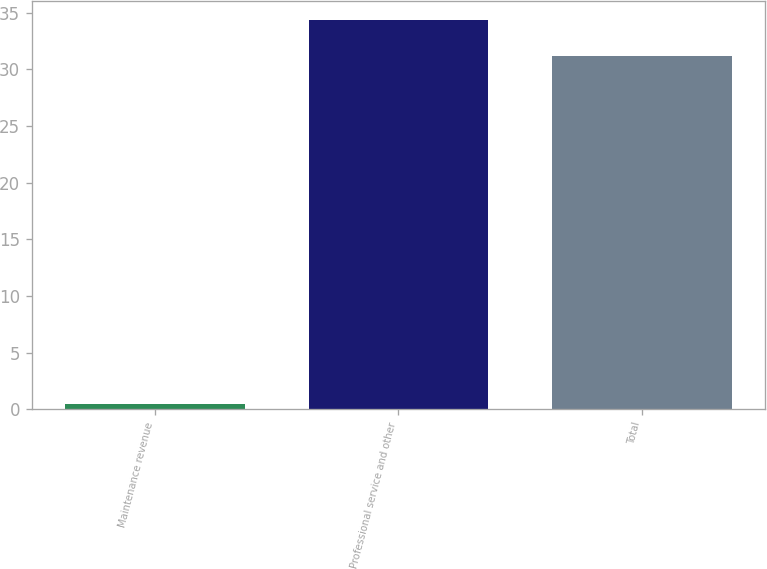Convert chart to OTSL. <chart><loc_0><loc_0><loc_500><loc_500><bar_chart><fcel>Maintenance revenue<fcel>Professional service and other<fcel>Total<nl><fcel>0.5<fcel>34.32<fcel>31.2<nl></chart> 